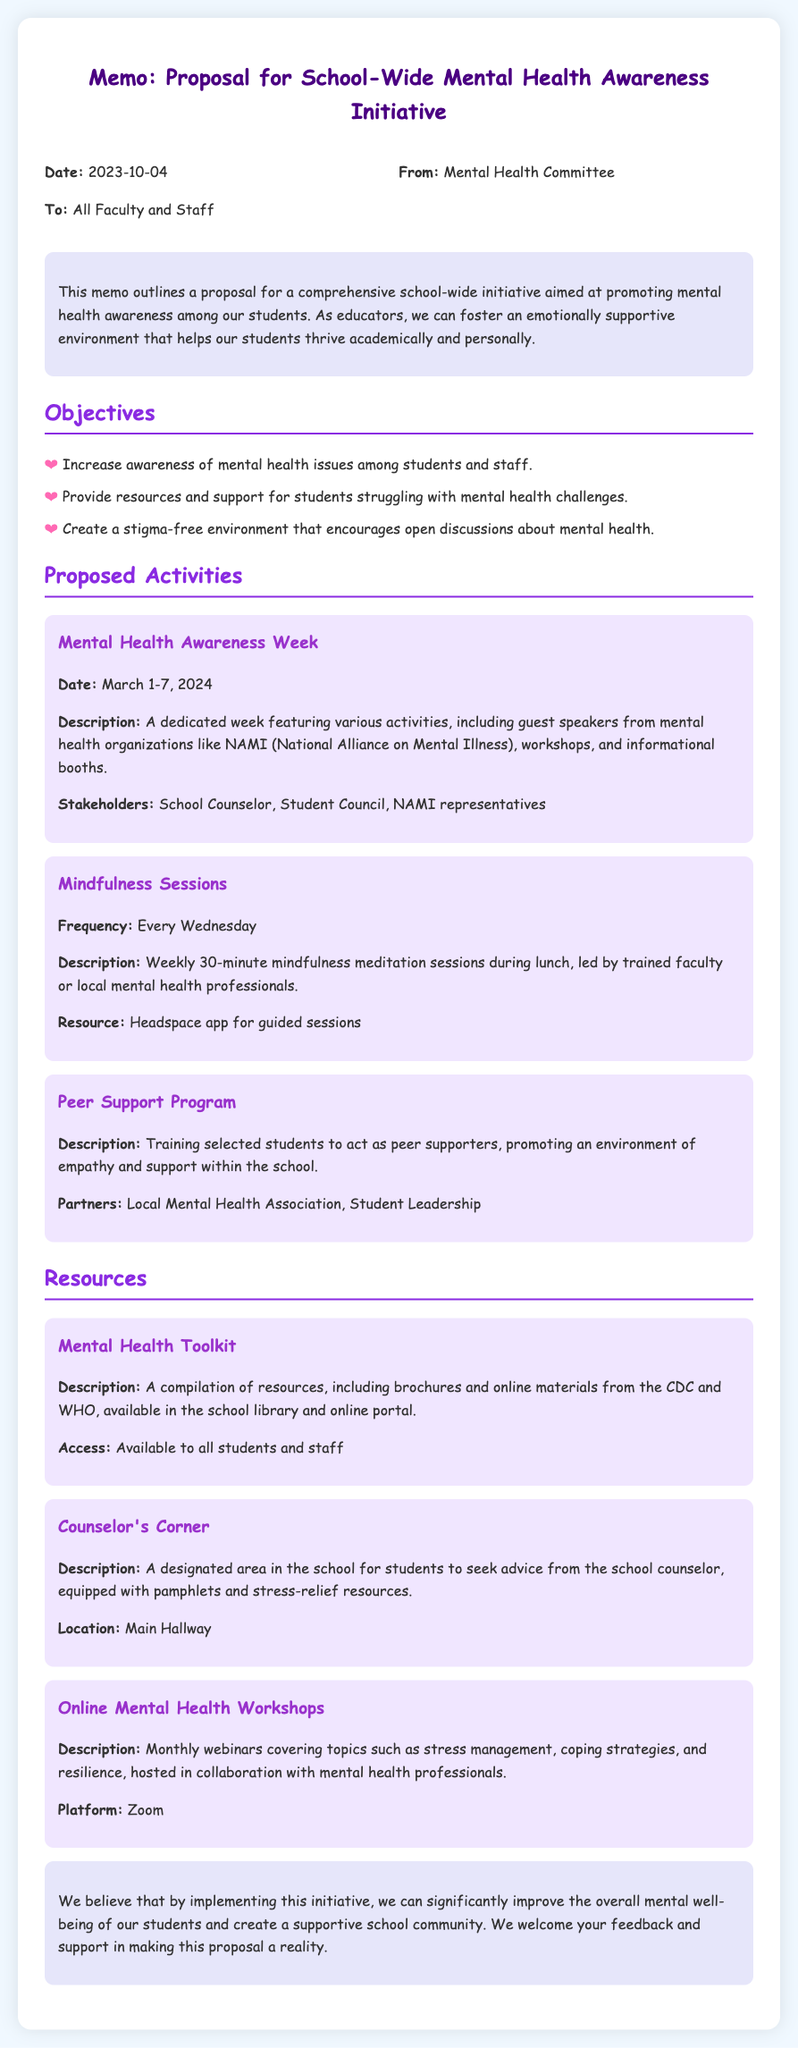What is the date of the proposal? The date of the proposal is mentioned in the header of the memo.
Answer: 2023-10-04 Who is the memo addressed to? The memo specifies the intended audience in the header section.
Answer: All Faculty and Staff What initiative is proposed in this memo? The main topic of the memo outlines the goal of the initiative.
Answer: Mental Health Awareness Initiative When is Mental Health Awareness Week scheduled? The specific dates for this week are provided under the proposed activities section.
Answer: March 1-7, 2024 How often are the mindfulness sessions held? The frequency of these sessions is explicitly mentioned in their description.
Answer: Every Wednesday What organization is involved in the Peer Support Program? The partnerships for this program are detailed in the activities section.
Answer: Local Mental Health Association What type of resources is included in the Mental Health Toolkit? The description of the toolkit indicates what it contains.
Answer: Brochures and online materials Where is the Counselor's Corner located? The location of this resource is indicated in its description.
Answer: Main Hallway What is the platform for the online mental health workshops? The platform for hosting these workshops is specified in the resources section.
Answer: Zoom 